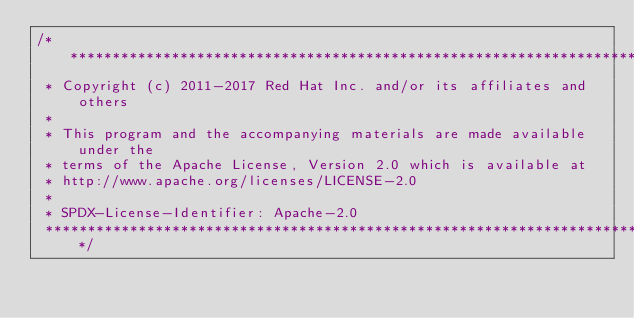<code> <loc_0><loc_0><loc_500><loc_500><_Ceylon_>/********************************************************************************
 * Copyright (c) 2011-2017 Red Hat Inc. and/or its affiliates and others
 *
 * This program and the accompanying materials are made available under the 
 * terms of the Apache License, Version 2.0 which is available at
 * http://www.apache.org/licenses/LICENSE-2.0
 *
 * SPDX-License-Identifier: Apache-2.0 
 ********************************************************************************/</code> 